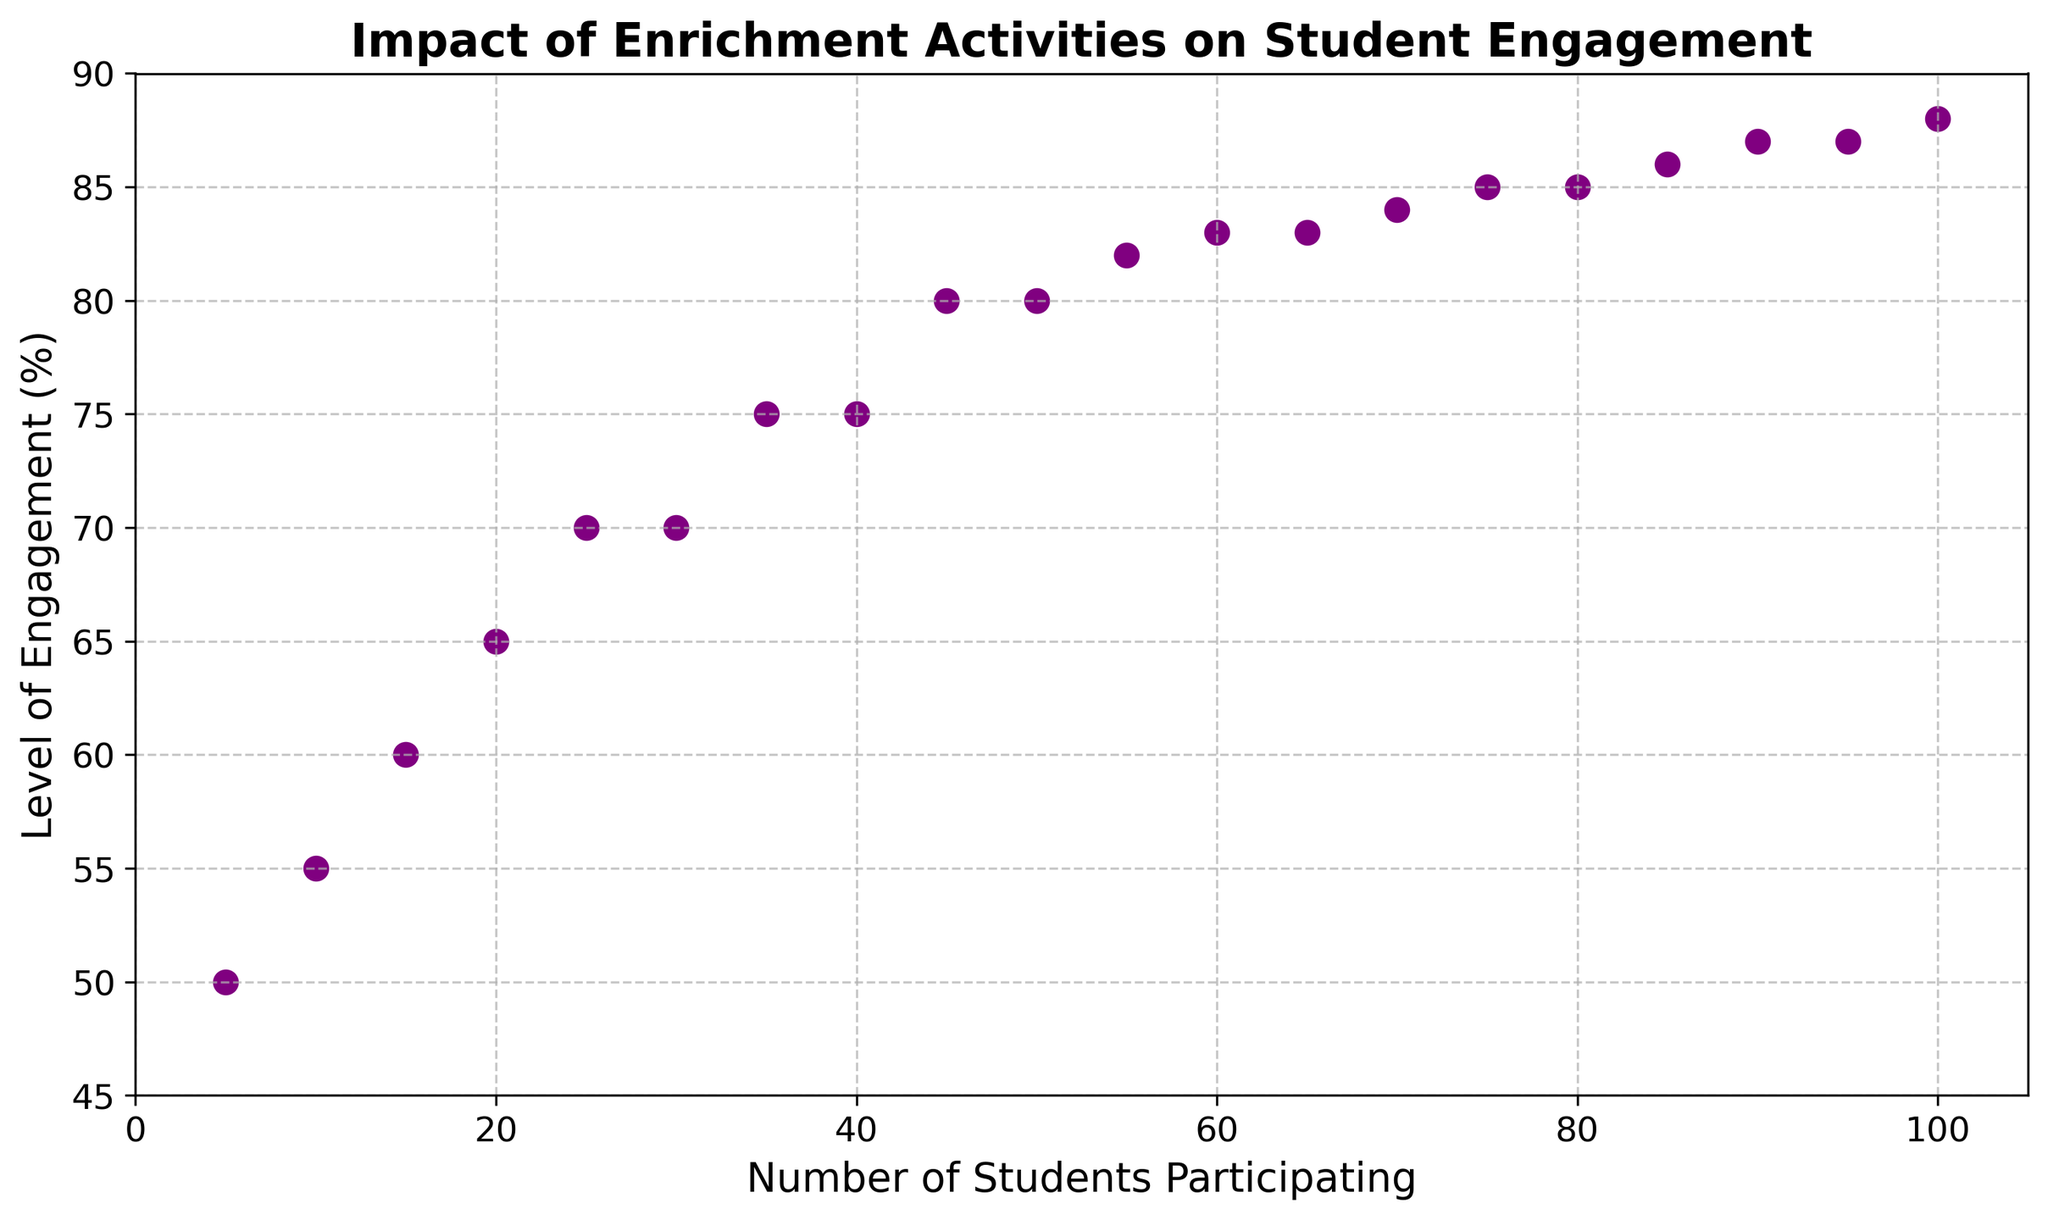How does the level of engagement change as the number of students increases? The level of engagement generally increases as the number of students increases. Specifically, you can see a clear upward trend in the scatter plot, where points are higher on the y-axis as you move to the right on the x-axis.
Answer: The level of engagement generally increases Which number of students participating corresponds to the first plateau in the level of engagement? The scatter plot shows that the level of engagement plateaus at 70% when the number of students participating is between 25 and 30.
Answer: Between 25 and 30 students What is the difference in engagement levels between 40 students and 50 students participating? At 40 students, the level of engagement is 75%. At 50 students, it is 80%. The difference is 80% - 75% = 5%.
Answer: 5% What is the average level of engagement for the range of students from 5 to 50? The levels of engagement for 5, 10, 15, 20, 25, 30, 35, 40, 45, and 50 students are 50, 55, 60, 65, 70, 70, 75, 75, 80, and 80 respectively. The sum is 680. There are 10 data points, so the average is 680 / 10 = 68%.
Answer: 68% Does any point show a sudden drop in engagement levels? The scatter plot shows a continuous or stable increase without any sudden drops in engagement levels.
Answer: No sudden drop Between 60 and 70 students, is there a significant increase in engagement? For 60 students, the level of engagement is 83%. For 65 and 70 students, it is unchanged at 83% and 84%, respectively. The increase is minimal.
Answer: Minimal increase Which number of students sees the highest engagement level? The highest engagement level spotted on the scatter plot is 88%, and it occurs when there are 100 students participating.
Answer: 100 students Is there a point where the engagement levels stay the same for consecutive data points? Yes, the levels of engagement stay the same at 70% between 25 and 30 students and also at 85% between 75 and 80 students.
Answer: Yes, at 25-30 and 75-80 students At what student number does the engagement level first reach 75%? According to the scatter plot, the engagement level first reaches 75% when there are 35 students participating.
Answer: 35 students 